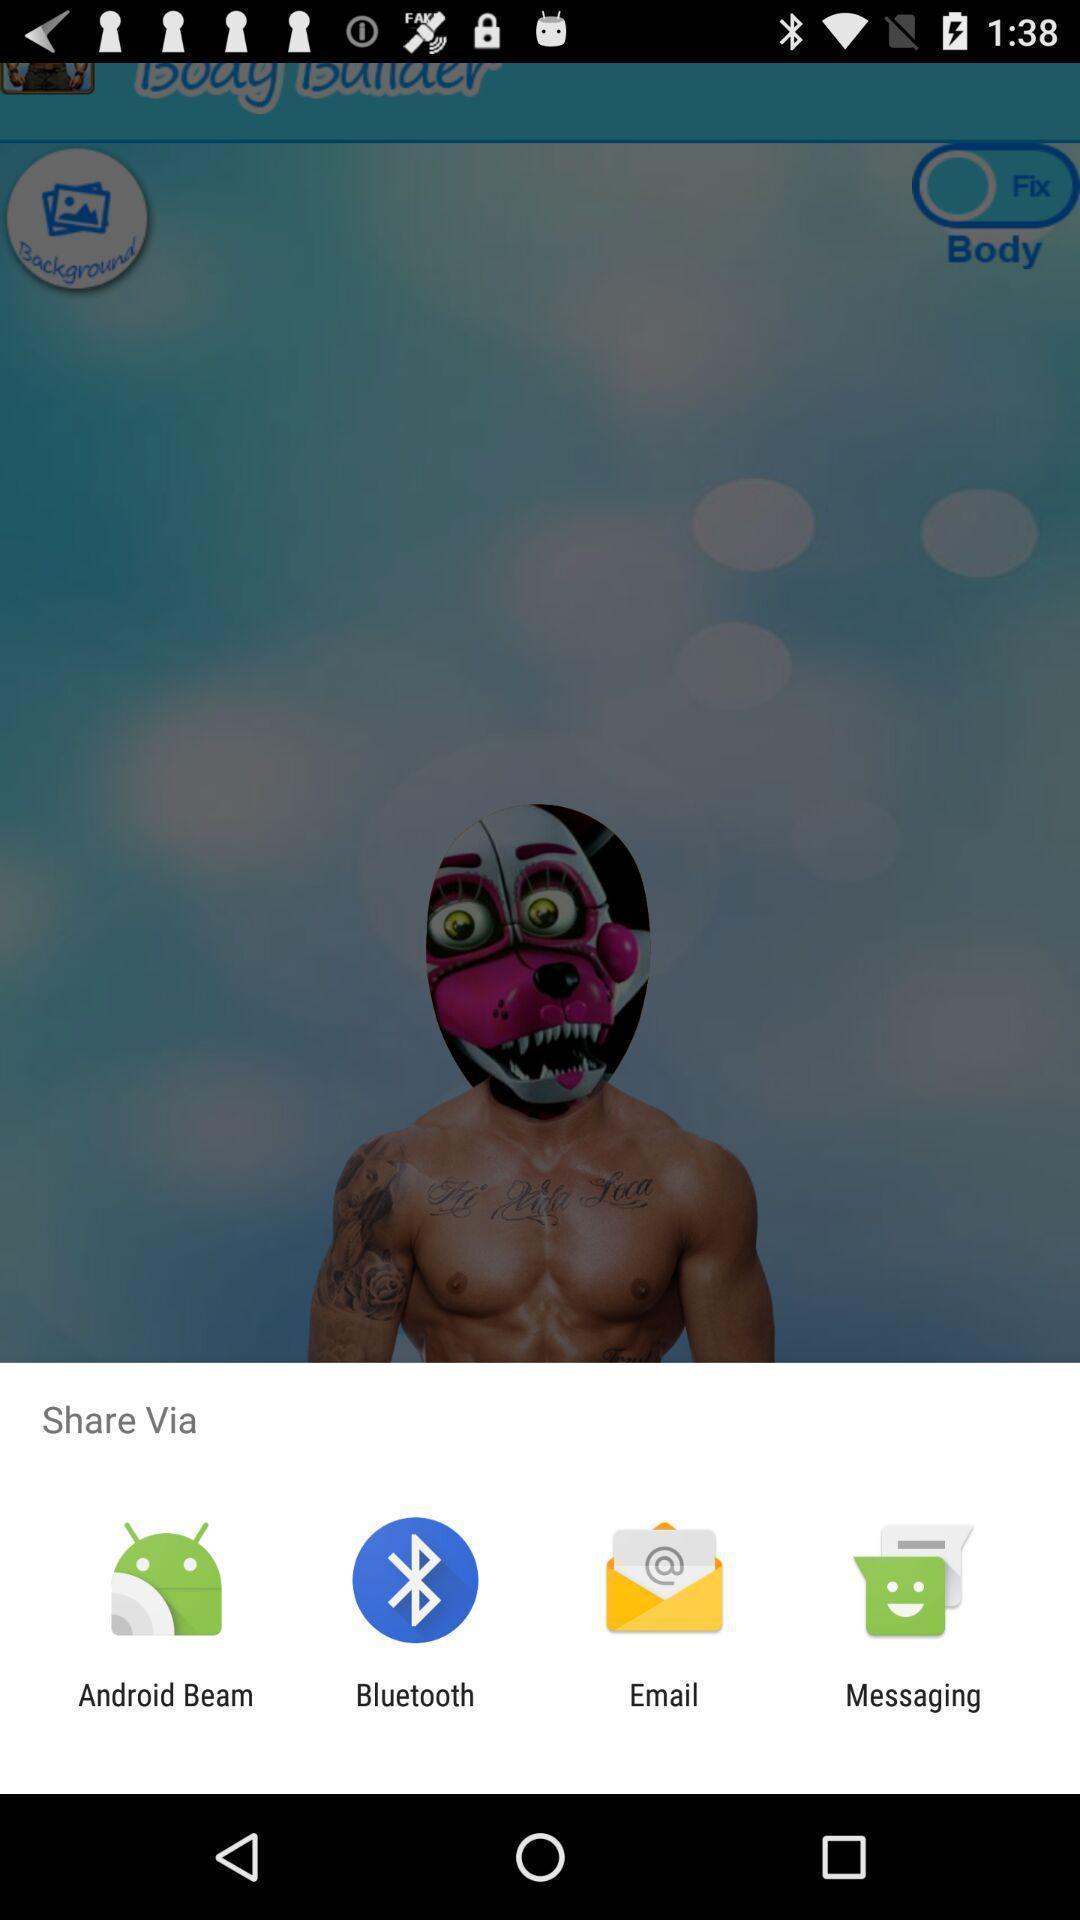What can you discern from this picture? Pop-up showing various sharing options. 